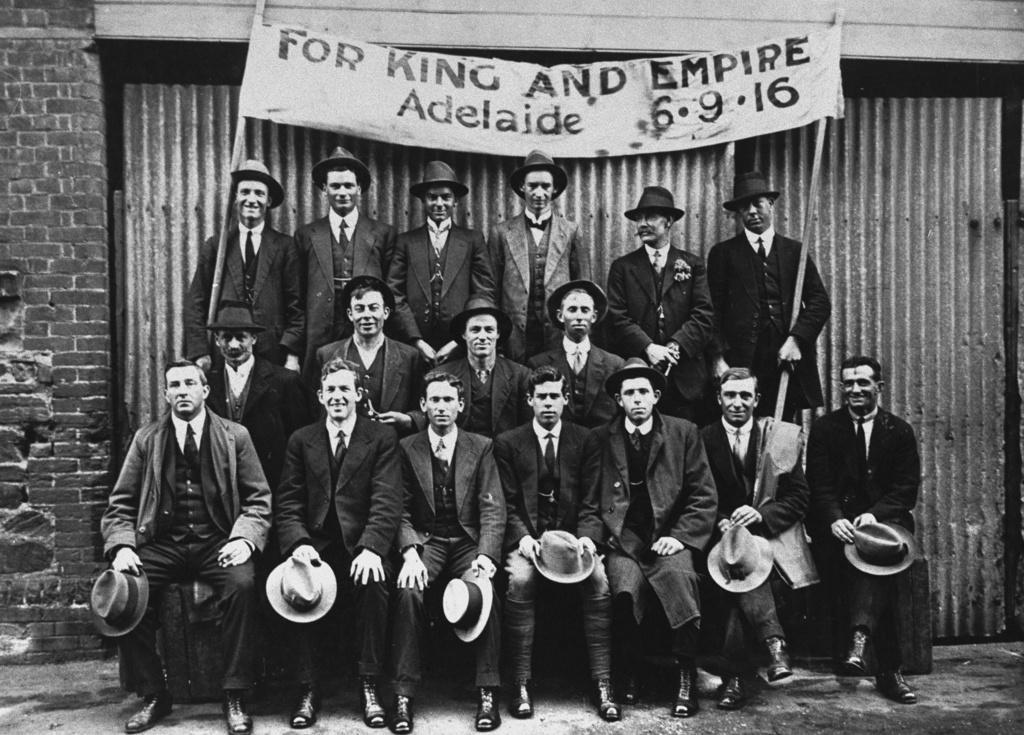How would you summarize this image in a sentence or two? In the image we can see there are people sitting and holding hats and others are standing and holding banner in their hand and wearing hat. They are wearing formal suits and the image is in black and white colour. 